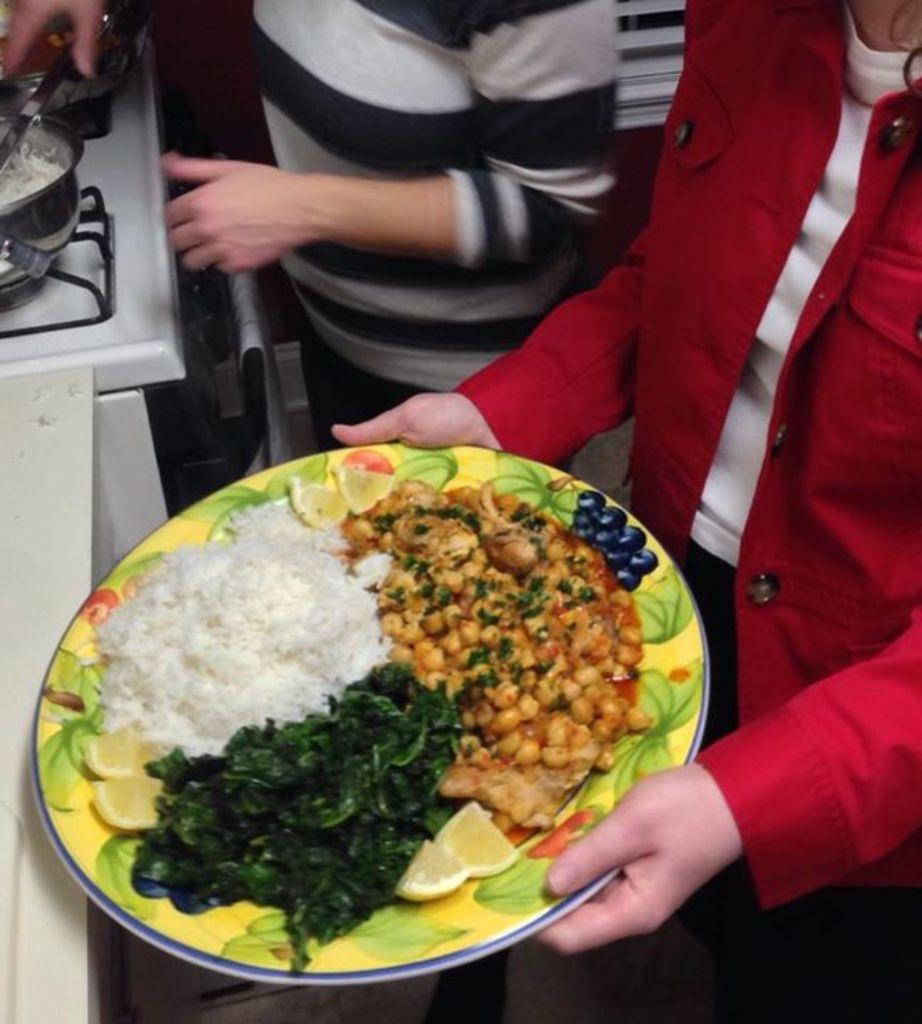What is the person holding in the image? The person is holding a plate with food. What can be seen on the stove in the image? There is a bowl with rice on a stove. What is the other person doing in the image? The other person is standing in front of the stove. What type of building is visible in the image? There is no building visible in the image; it focuses on the people and the stove. 